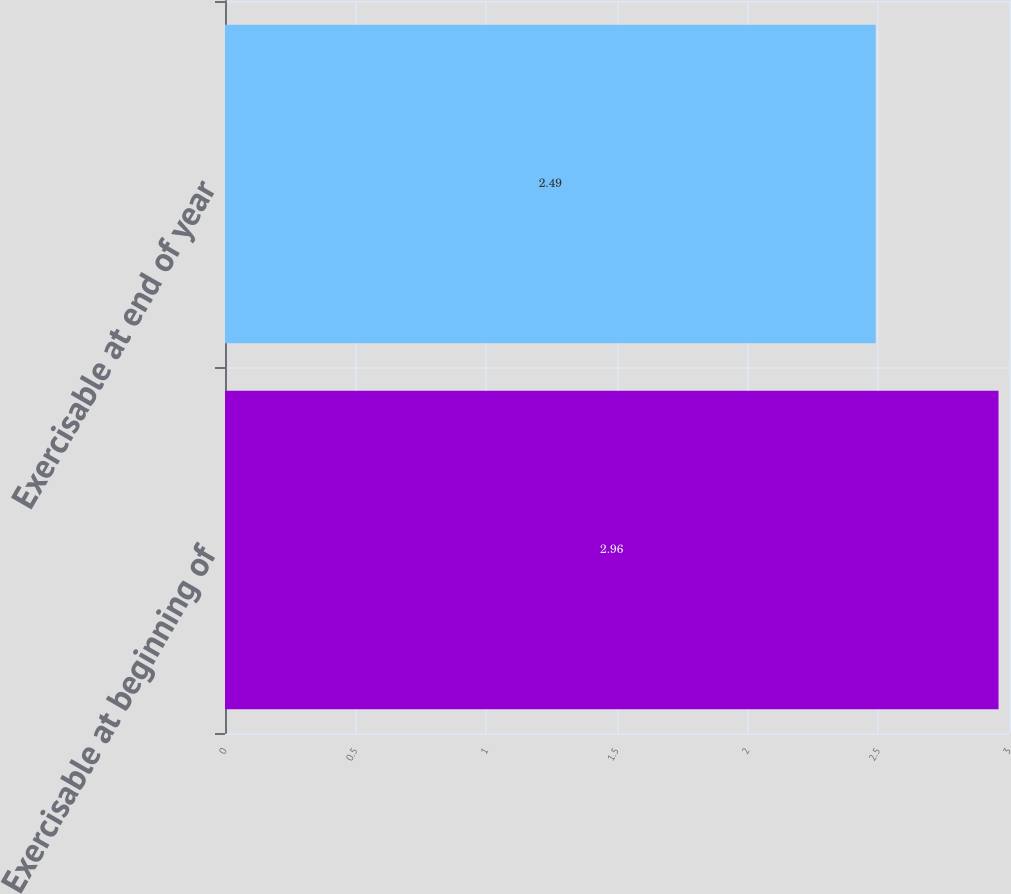Convert chart to OTSL. <chart><loc_0><loc_0><loc_500><loc_500><bar_chart><fcel>Exercisable at beginning of<fcel>Exercisable at end of year<nl><fcel>2.96<fcel>2.49<nl></chart> 